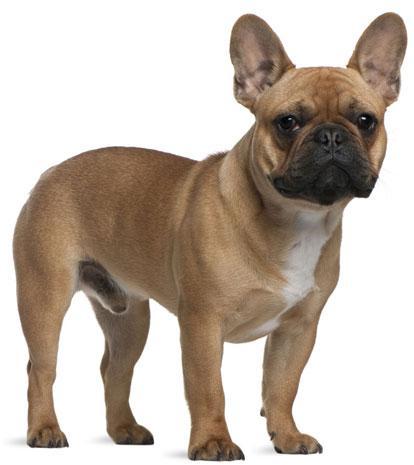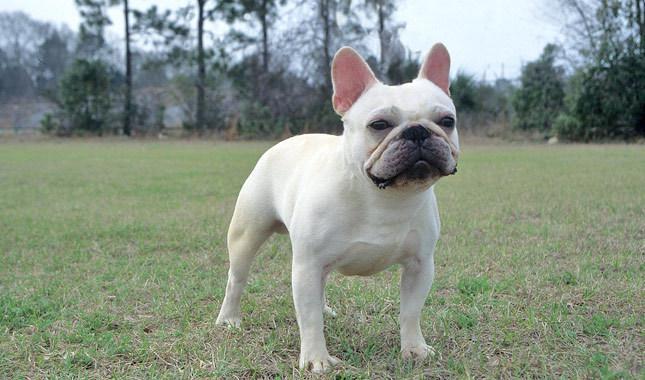The first image is the image on the left, the second image is the image on the right. Considering the images on both sides, is "the pupply on the left image has its head laying flat on a surface" valid? Answer yes or no. No. 